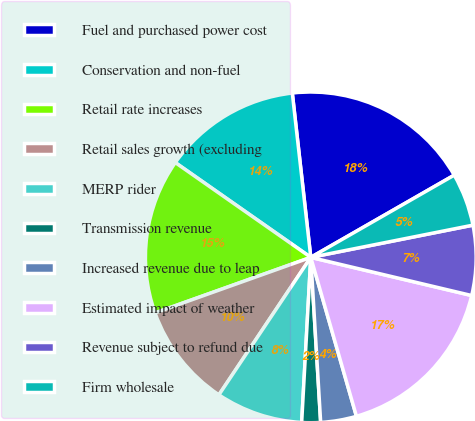<chart> <loc_0><loc_0><loc_500><loc_500><pie_chart><fcel>Fuel and purchased power cost<fcel>Conservation and non-fuel<fcel>Retail rate increases<fcel>Retail sales growth (excluding<fcel>MERP rider<fcel>Transmission revenue<fcel>Increased revenue due to leap<fcel>Estimated impact of weather<fcel>Revenue subject to refund due<fcel>Firm wholesale<nl><fcel>18.5%<fcel>13.5%<fcel>15.17%<fcel>10.17%<fcel>8.5%<fcel>1.83%<fcel>3.5%<fcel>16.84%<fcel>6.83%<fcel>5.16%<nl></chart> 